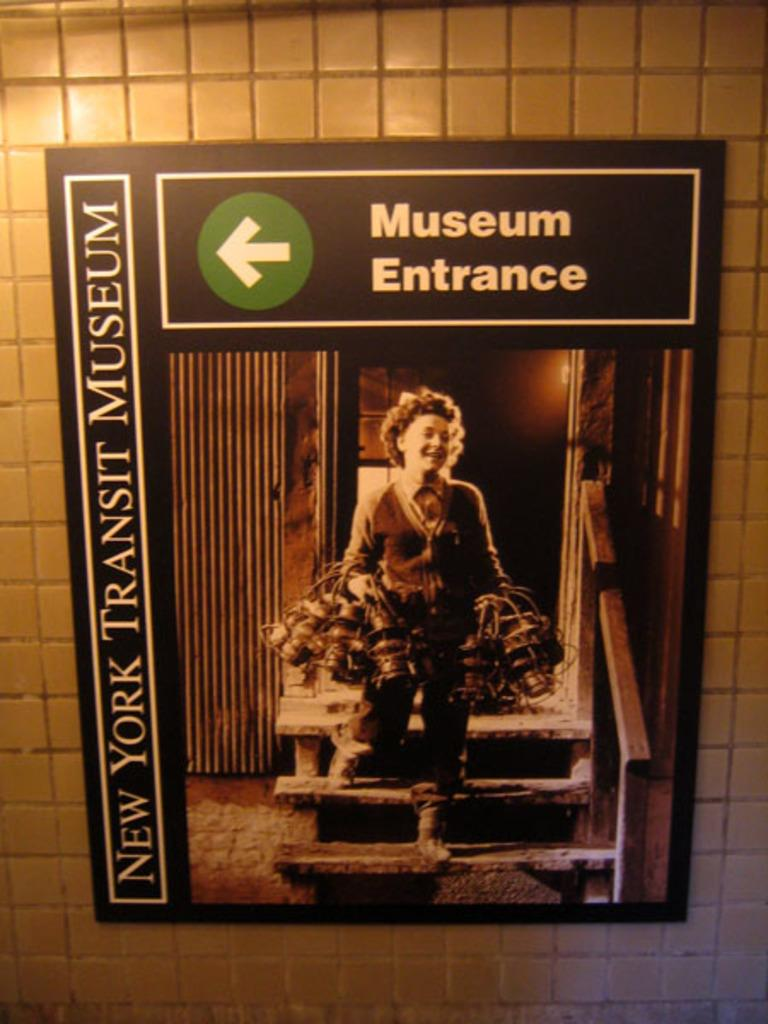<image>
Create a compact narrative representing the image presented. Poster on a wall saying the Museum Entrance is to the left. 